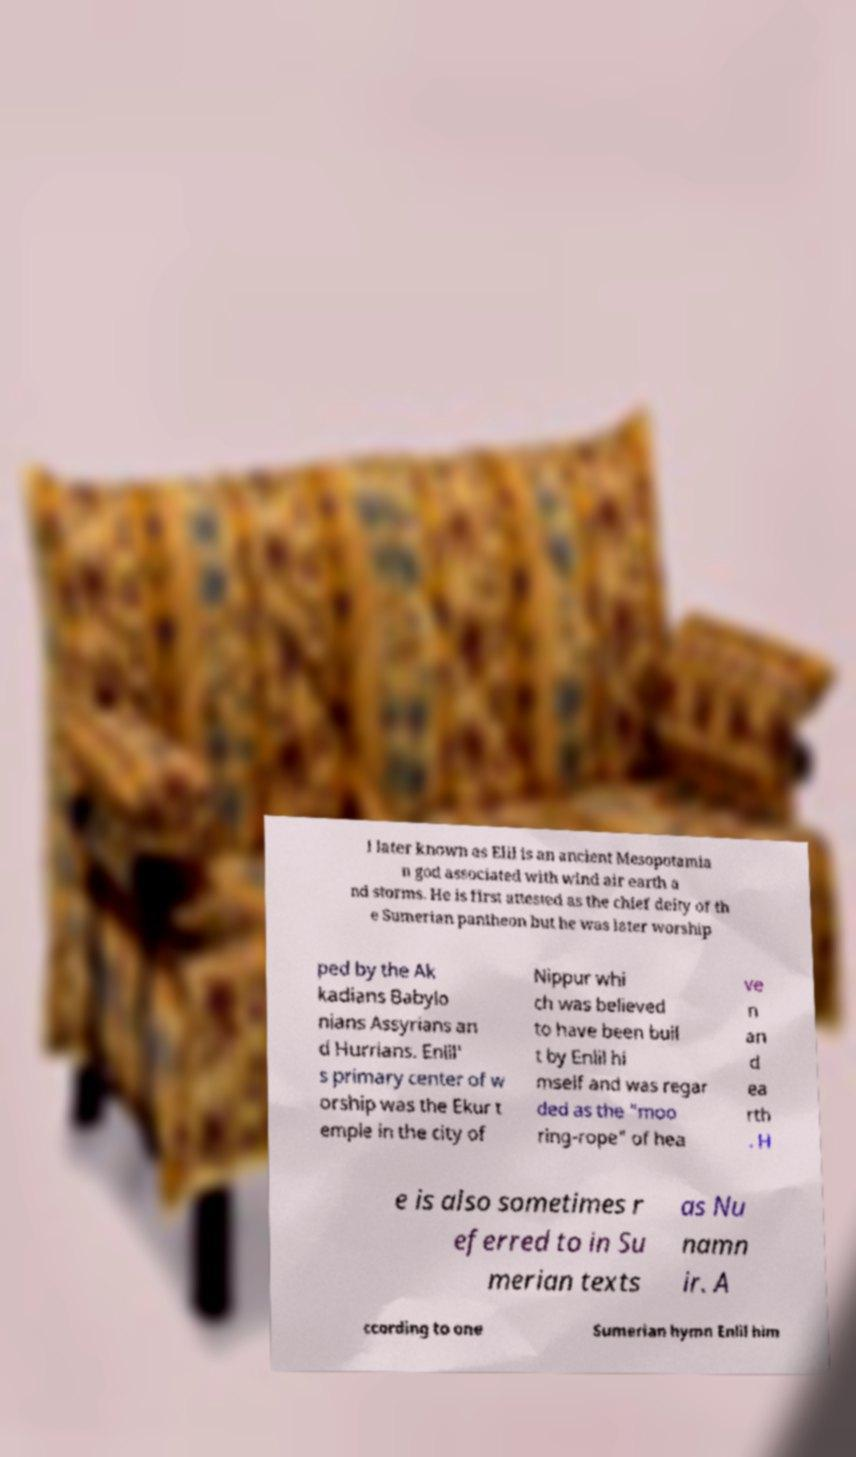Please read and relay the text visible in this image. What does it say? l later known as Elil is an ancient Mesopotamia n god associated with wind air earth a nd storms. He is first attested as the chief deity of th e Sumerian pantheon but he was later worship ped by the Ak kadians Babylo nians Assyrians an d Hurrians. Enlil' s primary center of w orship was the Ekur t emple in the city of Nippur whi ch was believed to have been buil t by Enlil hi mself and was regar ded as the "moo ring-rope" of hea ve n an d ea rth . H e is also sometimes r eferred to in Su merian texts as Nu namn ir. A ccording to one Sumerian hymn Enlil him 